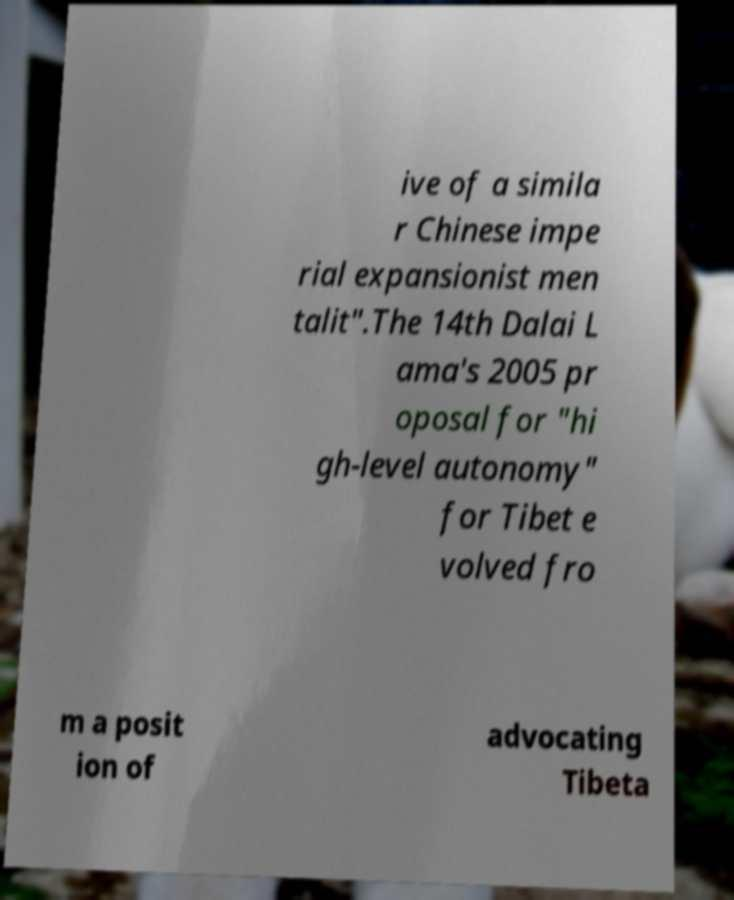Could you extract and type out the text from this image? ive of a simila r Chinese impe rial expansionist men talit".The 14th Dalai L ama's 2005 pr oposal for "hi gh-level autonomy" for Tibet e volved fro m a posit ion of advocating Tibeta 